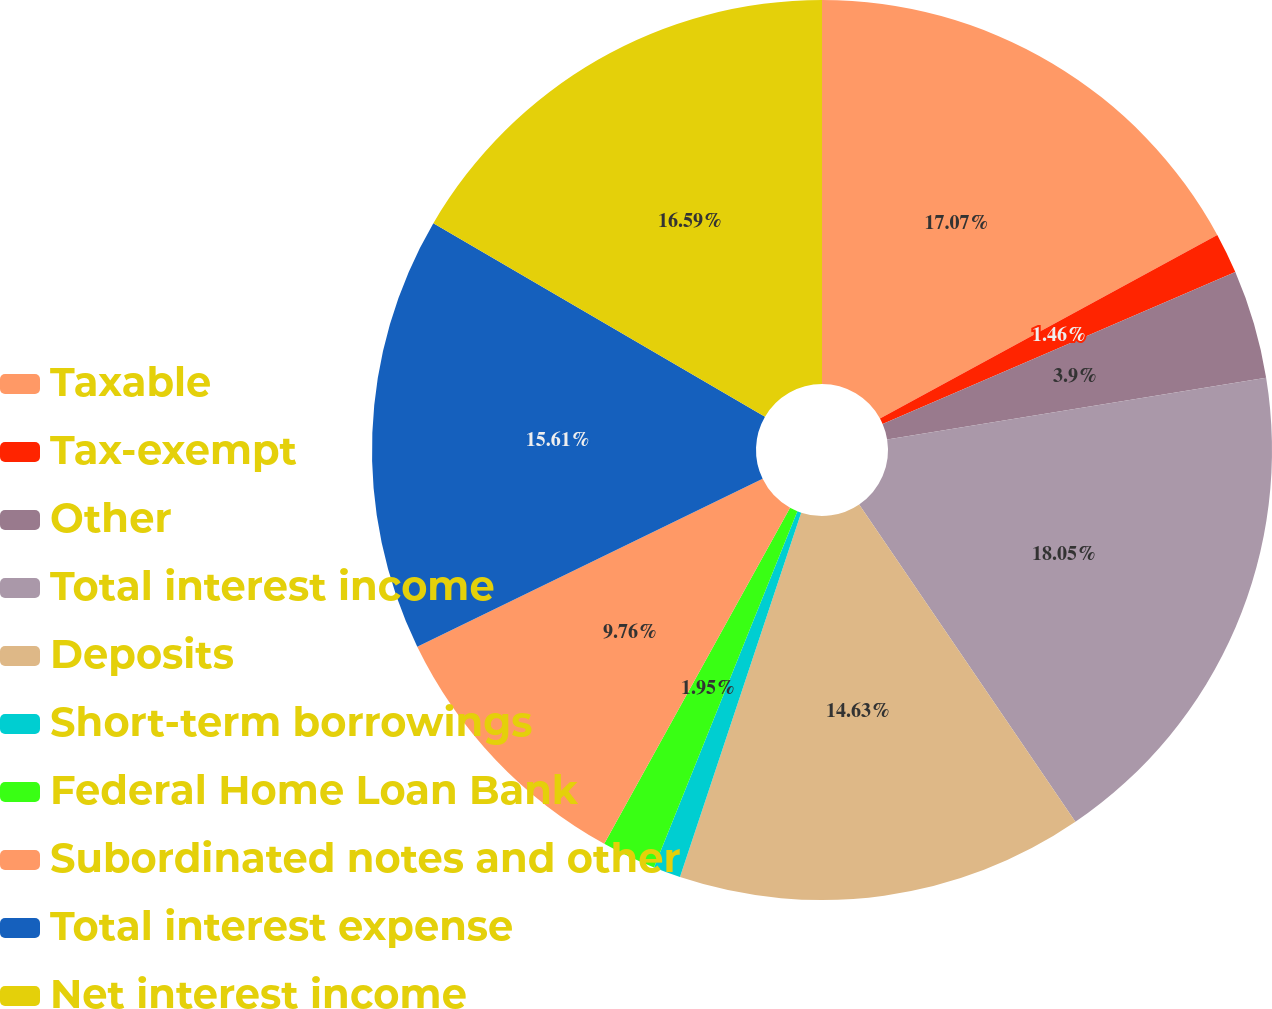Convert chart. <chart><loc_0><loc_0><loc_500><loc_500><pie_chart><fcel>Taxable<fcel>Tax-exempt<fcel>Other<fcel>Total interest income<fcel>Deposits<fcel>Short-term borrowings<fcel>Federal Home Loan Bank<fcel>Subordinated notes and other<fcel>Total interest expense<fcel>Net interest income<nl><fcel>17.07%<fcel>1.46%<fcel>3.9%<fcel>18.05%<fcel>14.63%<fcel>0.98%<fcel>1.95%<fcel>9.76%<fcel>15.61%<fcel>16.59%<nl></chart> 